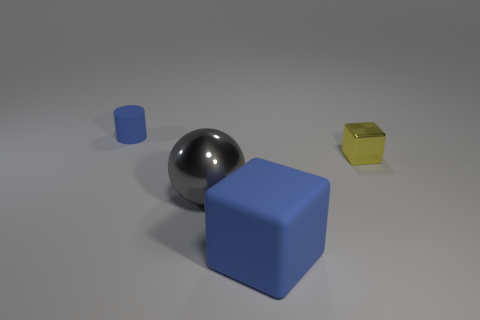How would you describe the various shapes and materials visible in the scene? In the image, we see an assortment of geometric objects, including a sizable blue cube, a smaller blue cylinder, a reflective metallic sphere, and a little yellow cube that might be a reflective, translucent material. The objects are arranged on a flat surface with a neutral background, highlighting their distinct forms and textures. 